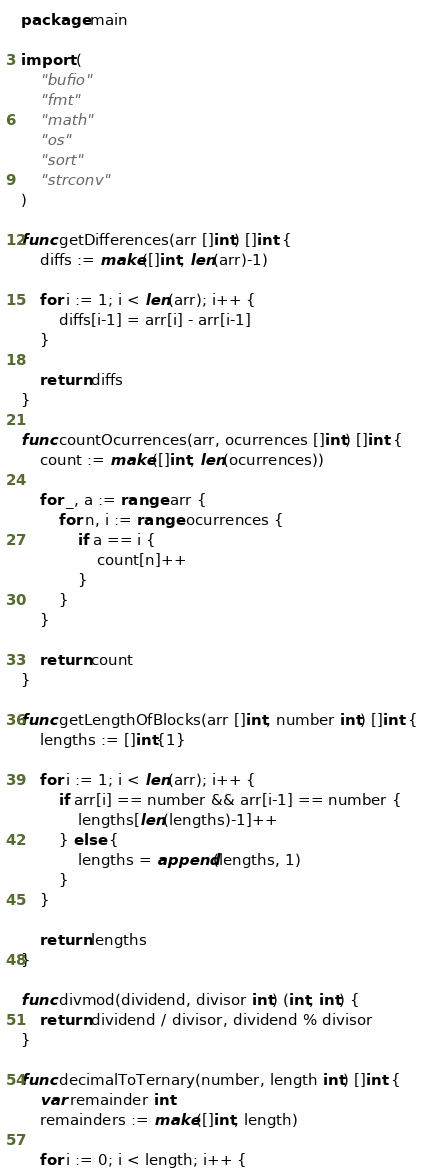Convert code to text. <code><loc_0><loc_0><loc_500><loc_500><_Go_>package main

import (
	"bufio"
	"fmt"
	"math"
	"os"
	"sort"
	"strconv"
)

func getDifferences(arr []int) []int {
	diffs := make([]int, len(arr)-1)

	for i := 1; i < len(arr); i++ {
		diffs[i-1] = arr[i] - arr[i-1]
	}

	return diffs
}

func countOcurrences(arr, ocurrences []int) []int {
	count := make([]int, len(ocurrences))

	for _, a := range arr {
		for n, i := range ocurrences {
			if a == i {
				count[n]++
			}
		}
	}

	return count
}

func getLengthOfBlocks(arr []int, number int) []int {
	lengths := []int{1}

	for i := 1; i < len(arr); i++ {
		if arr[i] == number && arr[i-1] == number {
			lengths[len(lengths)-1]++
		} else {
			lengths = append(lengths, 1)
		}
	}

	return lengths
}

func divmod(dividend, divisor int) (int, int) {
	return dividend / divisor, dividend % divisor
}

func decimalToTernary(number, length int) []int {
	var remainder int
	remainders := make([]int, length)

	for i := 0; i < length; i++ {</code> 